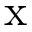<formula> <loc_0><loc_0><loc_500><loc_500>x</formula> 